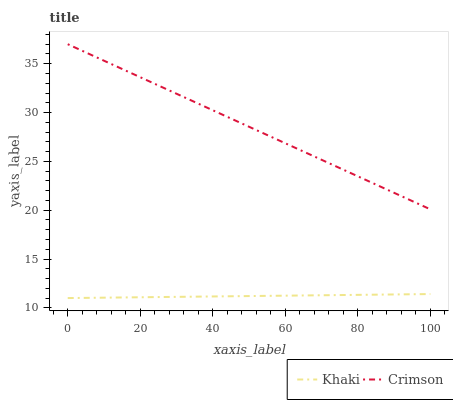Does Khaki have the minimum area under the curve?
Answer yes or no. Yes. Does Crimson have the maximum area under the curve?
Answer yes or no. Yes. Does Khaki have the maximum area under the curve?
Answer yes or no. No. Is Khaki the smoothest?
Answer yes or no. Yes. Is Crimson the roughest?
Answer yes or no. Yes. Is Khaki the roughest?
Answer yes or no. No. Does Crimson have the highest value?
Answer yes or no. Yes. Does Khaki have the highest value?
Answer yes or no. No. Is Khaki less than Crimson?
Answer yes or no. Yes. Is Crimson greater than Khaki?
Answer yes or no. Yes. Does Khaki intersect Crimson?
Answer yes or no. No. 